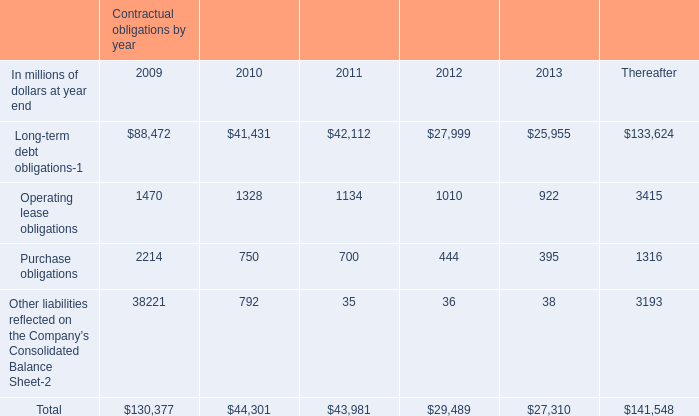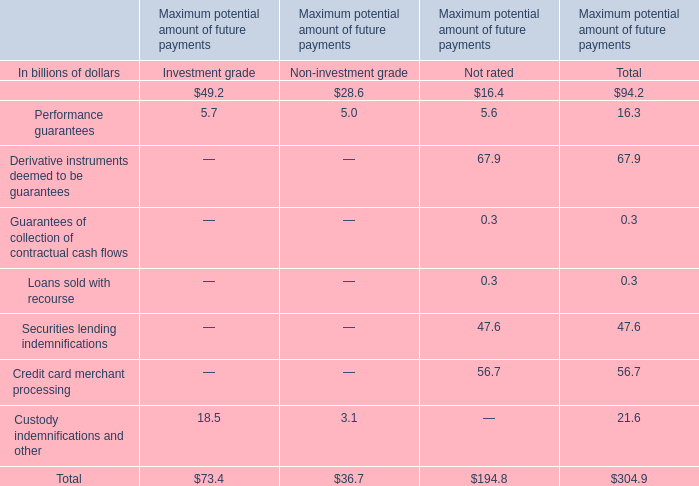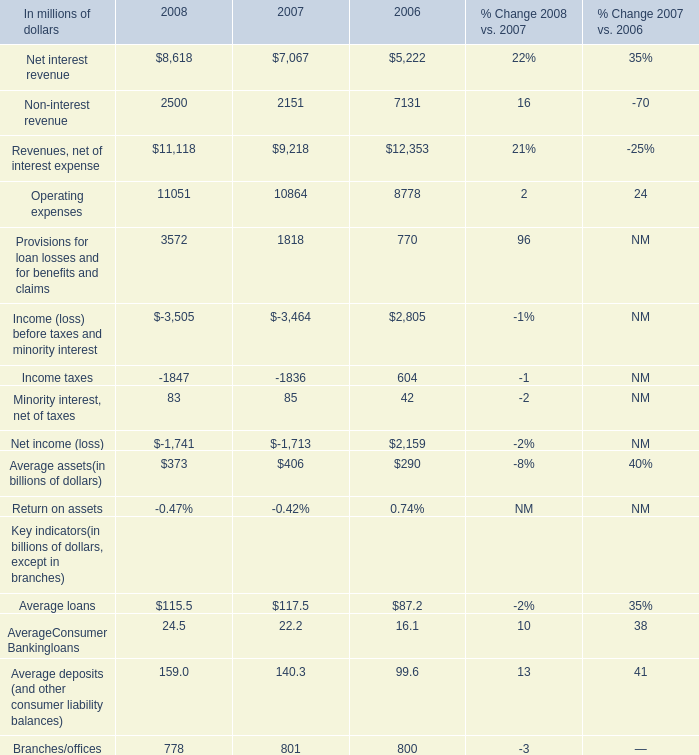In the yearwith lowest amount ofNon-interest revenue, what's the increasing rate of Operating expenses? 
Computations: ((10864 - 8778) / 10864)
Answer: 0.19201. 